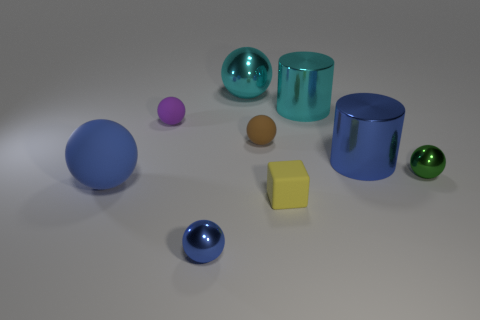What is the size of the shiny ball that is the same color as the large rubber object?
Keep it short and to the point. Small. Are there any brown objects that have the same material as the big blue ball?
Your answer should be compact. Yes. There is a big metal thing that is the same color as the large rubber thing; what is its shape?
Offer a terse response. Cylinder. What number of large shiny cylinders are there?
Provide a succinct answer. 2. How many blocks are purple rubber objects or large cyan objects?
Make the answer very short. 0. What color is the rubber block that is the same size as the brown thing?
Make the answer very short. Yellow. How many things are left of the big blue cylinder and in front of the big cyan ball?
Provide a short and direct response. 6. What is the material of the yellow object?
Offer a very short reply. Rubber. What number of objects are either tiny gray cylinders or cyan objects?
Ensure brevity in your answer.  2. Do the matte sphere that is to the right of the small blue metallic object and the blue metal object behind the large blue sphere have the same size?
Provide a short and direct response. No. 